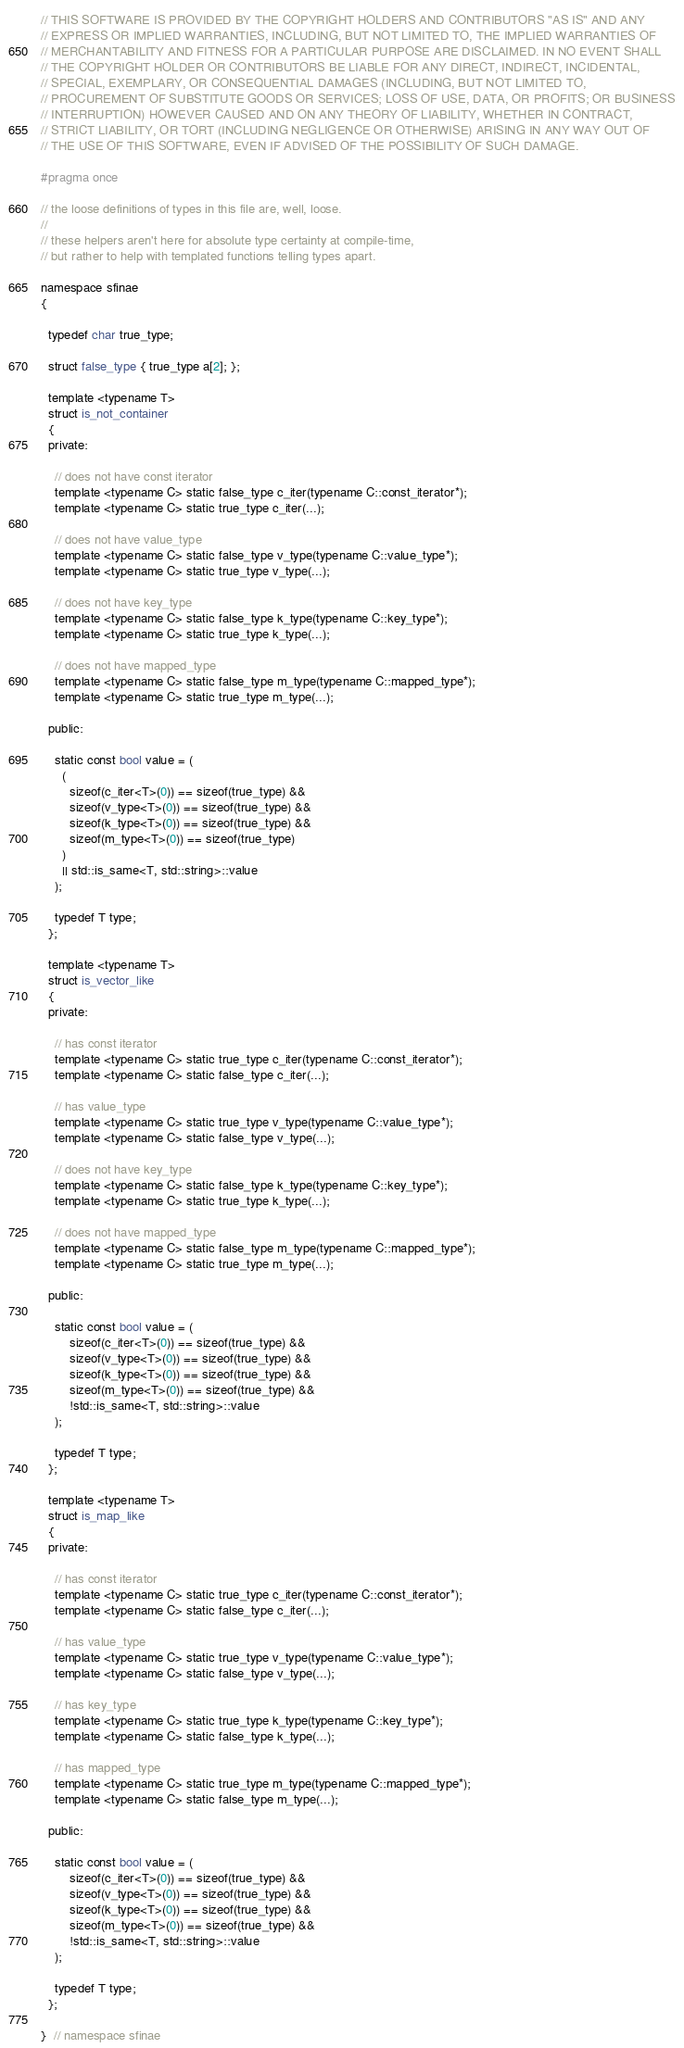<code> <loc_0><loc_0><loc_500><loc_500><_C_>// THIS SOFTWARE IS PROVIDED BY THE COPYRIGHT HOLDERS AND CONTRIBUTORS "AS IS" AND ANY
// EXPRESS OR IMPLIED WARRANTIES, INCLUDING, BUT NOT LIMITED TO, THE IMPLIED WARRANTIES OF
// MERCHANTABILITY AND FITNESS FOR A PARTICULAR PURPOSE ARE DISCLAIMED. IN NO EVENT SHALL
// THE COPYRIGHT HOLDER OR CONTRIBUTORS BE LIABLE FOR ANY DIRECT, INDIRECT, INCIDENTAL,
// SPECIAL, EXEMPLARY, OR CONSEQUENTIAL DAMAGES (INCLUDING, BUT NOT LIMITED TO,
// PROCUREMENT OF SUBSTITUTE GOODS OR SERVICES; LOSS OF USE, DATA, OR PROFITS; OR BUSINESS
// INTERRUPTION) HOWEVER CAUSED AND ON ANY THEORY OF LIABILITY, WHETHER IN CONTRACT,
// STRICT LIABILITY, OR TORT (INCLUDING NEGLIGENCE OR OTHERWISE) ARISING IN ANY WAY OUT OF
// THE USE OF THIS SOFTWARE, EVEN IF ADVISED OF THE POSSIBILITY OF SUCH DAMAGE.

#pragma once

// the loose definitions of types in this file are, well, loose.
//
// these helpers aren't here for absolute type certainty at compile-time,
// but rather to help with templated functions telling types apart.

namespace sfinae
{

  typedef char true_type;

  struct false_type { true_type a[2]; };

  template <typename T>
  struct is_not_container
  {
  private:

    // does not have const iterator
    template <typename C> static false_type c_iter(typename C::const_iterator*);
    template <typename C> static true_type c_iter(...);

    // does not have value_type
    template <typename C> static false_type v_type(typename C::value_type*);
    template <typename C> static true_type v_type(...);

    // does not have key_type
    template <typename C> static false_type k_type(typename C::key_type*);
    template <typename C> static true_type k_type(...);

    // does not have mapped_type
    template <typename C> static false_type m_type(typename C::mapped_type*);
    template <typename C> static true_type m_type(...);

  public:

    static const bool value = (
      (
        sizeof(c_iter<T>(0)) == sizeof(true_type) &&
        sizeof(v_type<T>(0)) == sizeof(true_type) &&
        sizeof(k_type<T>(0)) == sizeof(true_type) &&
        sizeof(m_type<T>(0)) == sizeof(true_type)
      )
      || std::is_same<T, std::string>::value
    );

    typedef T type;
  };

  template <typename T>
  struct is_vector_like
  {
  private:

    // has const iterator
    template <typename C> static true_type c_iter(typename C::const_iterator*);
    template <typename C> static false_type c_iter(...);

    // has value_type
    template <typename C> static true_type v_type(typename C::value_type*);
    template <typename C> static false_type v_type(...);

    // does not have key_type
    template <typename C> static false_type k_type(typename C::key_type*);
    template <typename C> static true_type k_type(...);

    // does not have mapped_type
    template <typename C> static false_type m_type(typename C::mapped_type*);
    template <typename C> static true_type m_type(...);

  public:

    static const bool value = (
        sizeof(c_iter<T>(0)) == sizeof(true_type) &&
        sizeof(v_type<T>(0)) == sizeof(true_type) &&
        sizeof(k_type<T>(0)) == sizeof(true_type) &&
        sizeof(m_type<T>(0)) == sizeof(true_type) &&
        !std::is_same<T, std::string>::value
    );

    typedef T type;
  };

  template <typename T>
  struct is_map_like
  {
  private:

    // has const iterator
    template <typename C> static true_type c_iter(typename C::const_iterator*);
    template <typename C> static false_type c_iter(...);

    // has value_type
    template <typename C> static true_type v_type(typename C::value_type*);
    template <typename C> static false_type v_type(...);

    // has key_type
    template <typename C> static true_type k_type(typename C::key_type*);
    template <typename C> static false_type k_type(...);

    // has mapped_type
    template <typename C> static true_type m_type(typename C::mapped_type*);
    template <typename C> static false_type m_type(...);

  public:

    static const bool value = (
        sizeof(c_iter<T>(0)) == sizeof(true_type) &&
        sizeof(v_type<T>(0)) == sizeof(true_type) &&
        sizeof(k_type<T>(0)) == sizeof(true_type) &&
        sizeof(m_type<T>(0)) == sizeof(true_type) &&
        !std::is_same<T, std::string>::value
    );

    typedef T type;
  };

}  // namespace sfinae
</code> 